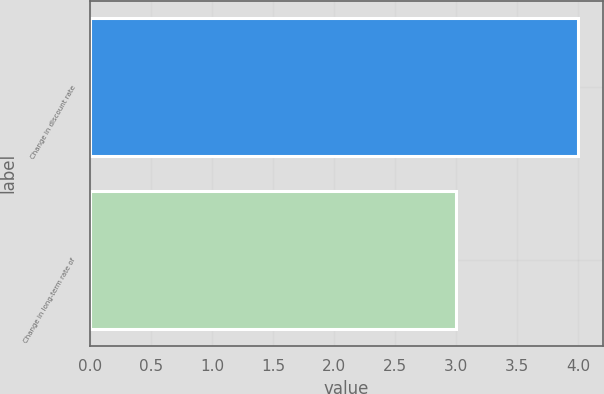Convert chart to OTSL. <chart><loc_0><loc_0><loc_500><loc_500><bar_chart><fcel>Change in discount rate<fcel>Change in long-term rate of<nl><fcel>4<fcel>3<nl></chart> 